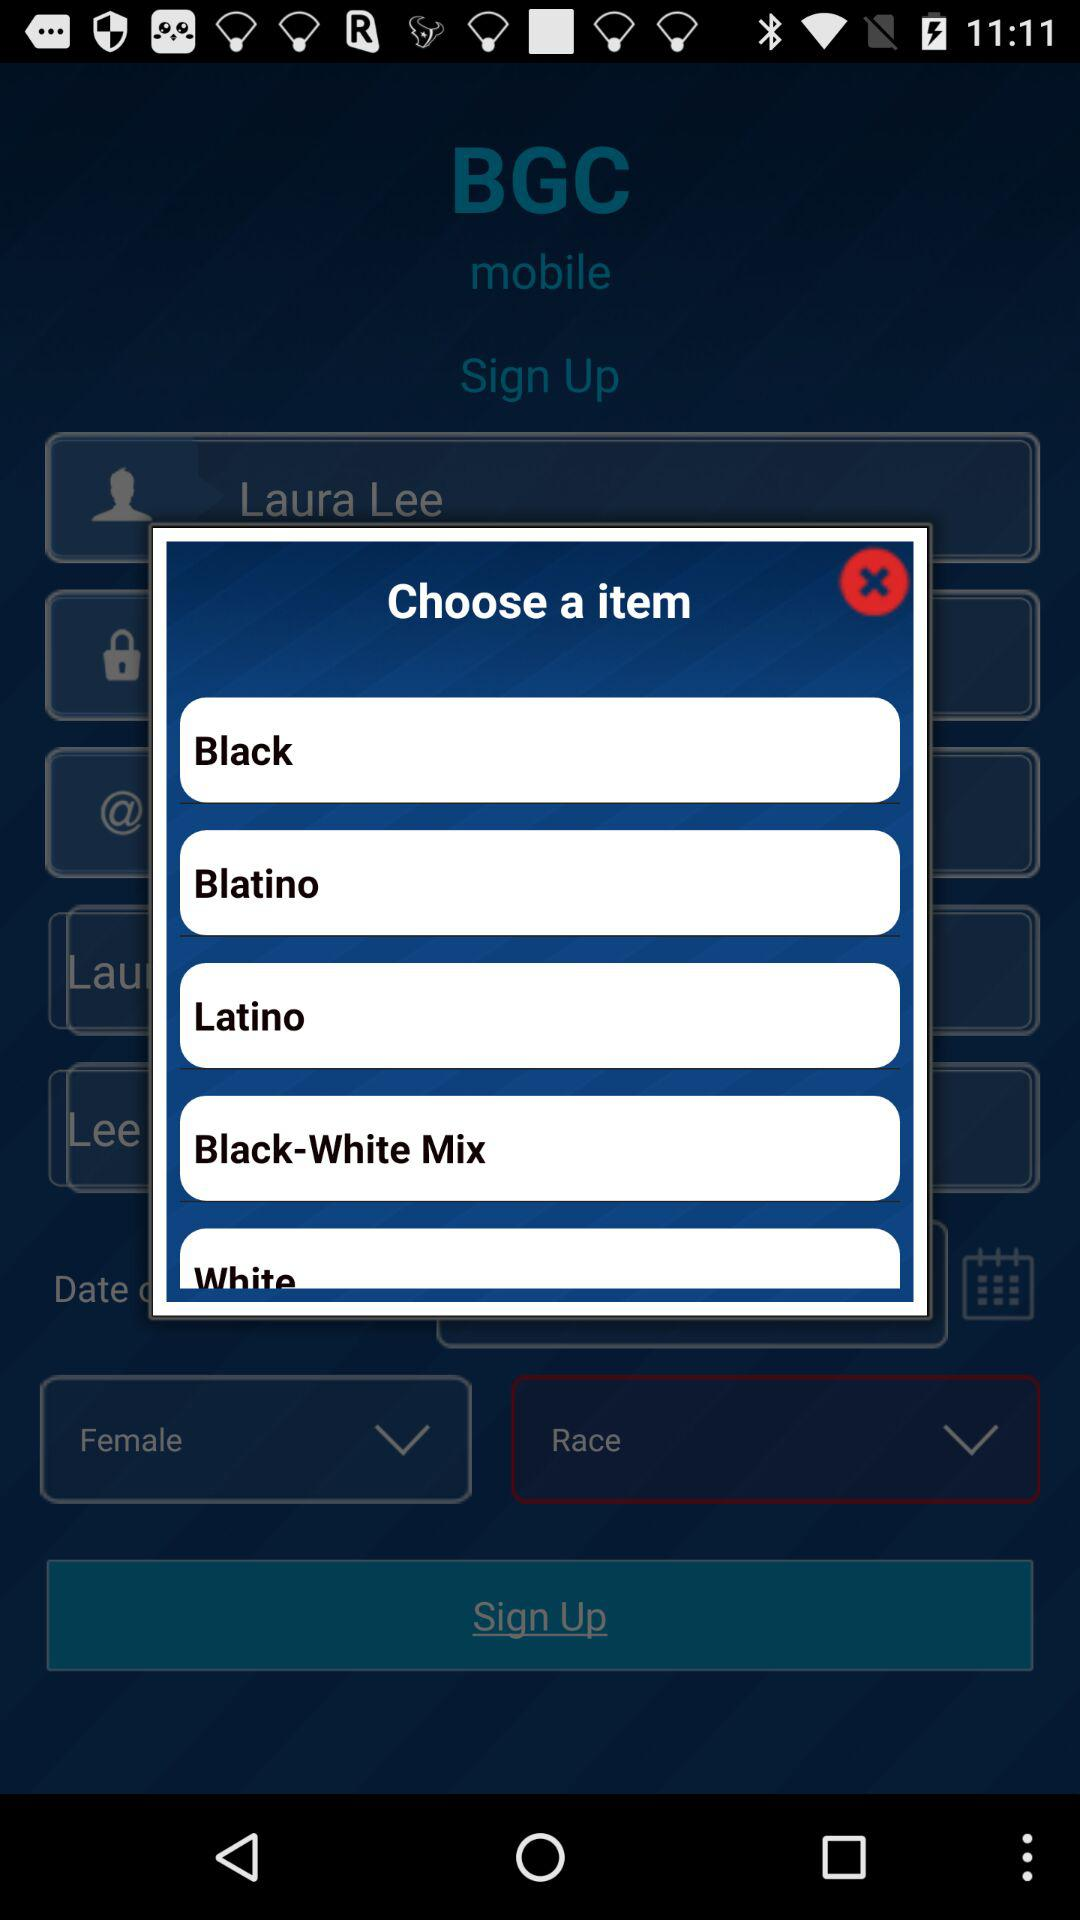What is the user's name? The user's name is Laura Lee. 